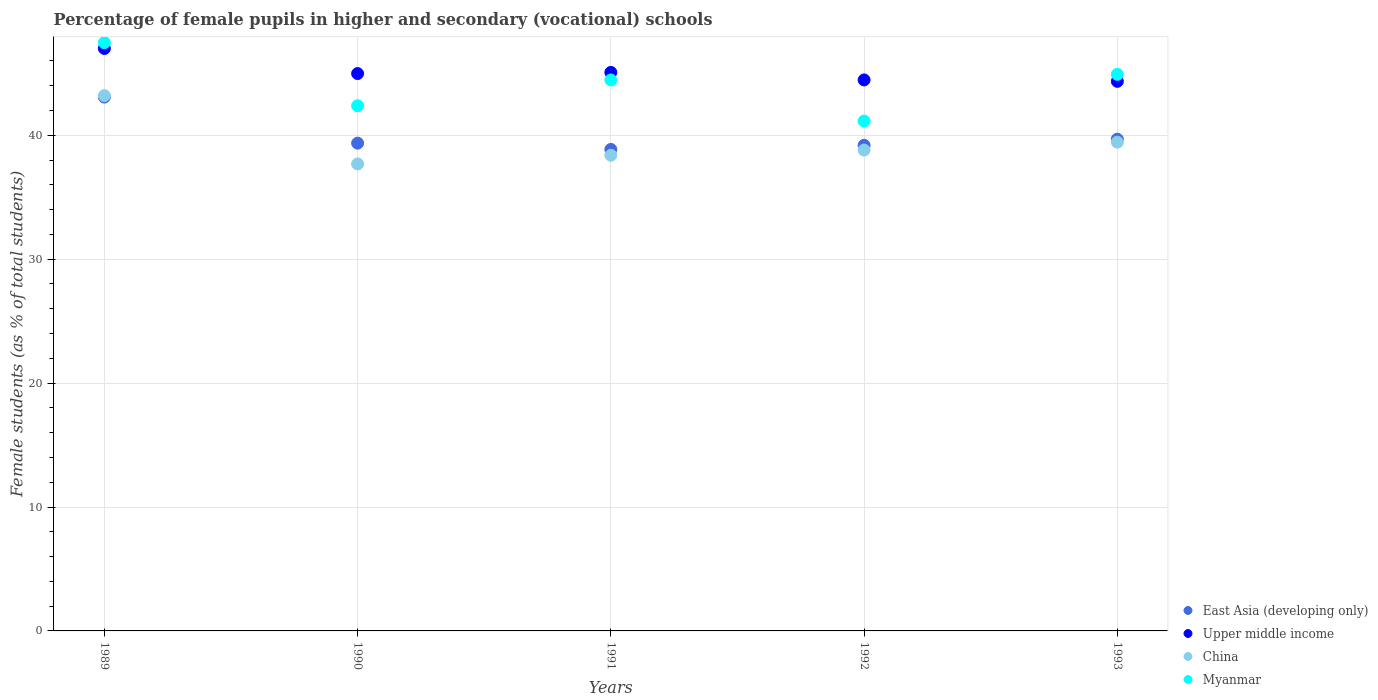How many different coloured dotlines are there?
Your answer should be very brief. 4. What is the percentage of female pupils in higher and secondary schools in Myanmar in 1989?
Your answer should be very brief. 47.48. Across all years, what is the maximum percentage of female pupils in higher and secondary schools in China?
Provide a short and direct response. 43.2. Across all years, what is the minimum percentage of female pupils in higher and secondary schools in East Asia (developing only)?
Offer a terse response. 38.86. What is the total percentage of female pupils in higher and secondary schools in East Asia (developing only) in the graph?
Keep it short and to the point. 200.19. What is the difference between the percentage of female pupils in higher and secondary schools in Upper middle income in 1989 and that in 1990?
Give a very brief answer. 2.03. What is the difference between the percentage of female pupils in higher and secondary schools in Myanmar in 1993 and the percentage of female pupils in higher and secondary schools in East Asia (developing only) in 1991?
Ensure brevity in your answer.  6.06. What is the average percentage of female pupils in higher and secondary schools in China per year?
Your answer should be very brief. 39.51. In the year 1993, what is the difference between the percentage of female pupils in higher and secondary schools in Upper middle income and percentage of female pupils in higher and secondary schools in China?
Give a very brief answer. 4.91. What is the ratio of the percentage of female pupils in higher and secondary schools in Upper middle income in 1991 to that in 1993?
Keep it short and to the point. 1.02. Is the percentage of female pupils in higher and secondary schools in China in 1992 less than that in 1993?
Your answer should be very brief. Yes. Is the difference between the percentage of female pupils in higher and secondary schools in Upper middle income in 1989 and 1993 greater than the difference between the percentage of female pupils in higher and secondary schools in China in 1989 and 1993?
Keep it short and to the point. No. What is the difference between the highest and the second highest percentage of female pupils in higher and secondary schools in East Asia (developing only)?
Ensure brevity in your answer.  3.4. What is the difference between the highest and the lowest percentage of female pupils in higher and secondary schools in Myanmar?
Offer a terse response. 6.33. Does the percentage of female pupils in higher and secondary schools in Upper middle income monotonically increase over the years?
Your response must be concise. No. Is the percentage of female pupils in higher and secondary schools in Upper middle income strictly greater than the percentage of female pupils in higher and secondary schools in China over the years?
Ensure brevity in your answer.  Yes. Is the percentage of female pupils in higher and secondary schools in Myanmar strictly less than the percentage of female pupils in higher and secondary schools in East Asia (developing only) over the years?
Your answer should be very brief. No. How many years are there in the graph?
Offer a terse response. 5. Does the graph contain any zero values?
Provide a succinct answer. No. What is the title of the graph?
Ensure brevity in your answer.  Percentage of female pupils in higher and secondary (vocational) schools. What is the label or title of the Y-axis?
Make the answer very short. Female students (as % of total students). What is the Female students (as % of total students) of East Asia (developing only) in 1989?
Offer a very short reply. 43.08. What is the Female students (as % of total students) in Upper middle income in 1989?
Provide a short and direct response. 47.01. What is the Female students (as % of total students) of China in 1989?
Your answer should be very brief. 43.2. What is the Female students (as % of total students) of Myanmar in 1989?
Your response must be concise. 47.48. What is the Female students (as % of total students) of East Asia (developing only) in 1990?
Ensure brevity in your answer.  39.37. What is the Female students (as % of total students) in Upper middle income in 1990?
Offer a very short reply. 44.98. What is the Female students (as % of total students) in China in 1990?
Offer a terse response. 37.69. What is the Female students (as % of total students) of Myanmar in 1990?
Your answer should be compact. 42.38. What is the Female students (as % of total students) of East Asia (developing only) in 1991?
Make the answer very short. 38.86. What is the Female students (as % of total students) in Upper middle income in 1991?
Your answer should be compact. 45.08. What is the Female students (as % of total students) in China in 1991?
Offer a very short reply. 38.39. What is the Female students (as % of total students) in Myanmar in 1991?
Your response must be concise. 44.47. What is the Female students (as % of total students) in East Asia (developing only) in 1992?
Provide a succinct answer. 39.19. What is the Female students (as % of total students) in Upper middle income in 1992?
Make the answer very short. 44.47. What is the Female students (as % of total students) in China in 1992?
Your answer should be very brief. 38.81. What is the Female students (as % of total students) of Myanmar in 1992?
Offer a very short reply. 41.15. What is the Female students (as % of total students) in East Asia (developing only) in 1993?
Make the answer very short. 39.68. What is the Female students (as % of total students) in Upper middle income in 1993?
Provide a short and direct response. 44.36. What is the Female students (as % of total students) in China in 1993?
Provide a short and direct response. 39.45. What is the Female students (as % of total students) of Myanmar in 1993?
Provide a succinct answer. 44.92. Across all years, what is the maximum Female students (as % of total students) of East Asia (developing only)?
Offer a terse response. 43.08. Across all years, what is the maximum Female students (as % of total students) in Upper middle income?
Ensure brevity in your answer.  47.01. Across all years, what is the maximum Female students (as % of total students) of China?
Your response must be concise. 43.2. Across all years, what is the maximum Female students (as % of total students) of Myanmar?
Offer a very short reply. 47.48. Across all years, what is the minimum Female students (as % of total students) in East Asia (developing only)?
Make the answer very short. 38.86. Across all years, what is the minimum Female students (as % of total students) in Upper middle income?
Make the answer very short. 44.36. Across all years, what is the minimum Female students (as % of total students) in China?
Keep it short and to the point. 37.69. Across all years, what is the minimum Female students (as % of total students) in Myanmar?
Give a very brief answer. 41.15. What is the total Female students (as % of total students) in East Asia (developing only) in the graph?
Offer a very short reply. 200.19. What is the total Female students (as % of total students) in Upper middle income in the graph?
Ensure brevity in your answer.  225.89. What is the total Female students (as % of total students) of China in the graph?
Your answer should be compact. 197.54. What is the total Female students (as % of total students) in Myanmar in the graph?
Your answer should be very brief. 220.4. What is the difference between the Female students (as % of total students) of East Asia (developing only) in 1989 and that in 1990?
Your answer should be compact. 3.72. What is the difference between the Female students (as % of total students) of Upper middle income in 1989 and that in 1990?
Your answer should be compact. 2.03. What is the difference between the Female students (as % of total students) in China in 1989 and that in 1990?
Keep it short and to the point. 5.51. What is the difference between the Female students (as % of total students) of Myanmar in 1989 and that in 1990?
Keep it short and to the point. 5.09. What is the difference between the Female students (as % of total students) in East Asia (developing only) in 1989 and that in 1991?
Make the answer very short. 4.22. What is the difference between the Female students (as % of total students) of Upper middle income in 1989 and that in 1991?
Your answer should be very brief. 1.93. What is the difference between the Female students (as % of total students) of China in 1989 and that in 1991?
Your answer should be very brief. 4.81. What is the difference between the Female students (as % of total students) in Myanmar in 1989 and that in 1991?
Your answer should be very brief. 3.01. What is the difference between the Female students (as % of total students) of East Asia (developing only) in 1989 and that in 1992?
Ensure brevity in your answer.  3.89. What is the difference between the Female students (as % of total students) in Upper middle income in 1989 and that in 1992?
Keep it short and to the point. 2.54. What is the difference between the Female students (as % of total students) of China in 1989 and that in 1992?
Give a very brief answer. 4.39. What is the difference between the Female students (as % of total students) of Myanmar in 1989 and that in 1992?
Keep it short and to the point. 6.33. What is the difference between the Female students (as % of total students) in East Asia (developing only) in 1989 and that in 1993?
Give a very brief answer. 3.4. What is the difference between the Female students (as % of total students) of Upper middle income in 1989 and that in 1993?
Provide a succinct answer. 2.65. What is the difference between the Female students (as % of total students) of China in 1989 and that in 1993?
Your answer should be very brief. 3.75. What is the difference between the Female students (as % of total students) of Myanmar in 1989 and that in 1993?
Keep it short and to the point. 2.56. What is the difference between the Female students (as % of total students) in East Asia (developing only) in 1990 and that in 1991?
Keep it short and to the point. 0.51. What is the difference between the Female students (as % of total students) of Upper middle income in 1990 and that in 1991?
Your response must be concise. -0.09. What is the difference between the Female students (as % of total students) in China in 1990 and that in 1991?
Your response must be concise. -0.7. What is the difference between the Female students (as % of total students) of Myanmar in 1990 and that in 1991?
Your answer should be compact. -2.08. What is the difference between the Female students (as % of total students) of East Asia (developing only) in 1990 and that in 1992?
Ensure brevity in your answer.  0.17. What is the difference between the Female students (as % of total students) in Upper middle income in 1990 and that in 1992?
Your answer should be very brief. 0.51. What is the difference between the Female students (as % of total students) of China in 1990 and that in 1992?
Your answer should be compact. -1.12. What is the difference between the Female students (as % of total students) of Myanmar in 1990 and that in 1992?
Your answer should be compact. 1.23. What is the difference between the Female students (as % of total students) in East Asia (developing only) in 1990 and that in 1993?
Make the answer very short. -0.32. What is the difference between the Female students (as % of total students) in Upper middle income in 1990 and that in 1993?
Make the answer very short. 0.63. What is the difference between the Female students (as % of total students) in China in 1990 and that in 1993?
Offer a very short reply. -1.76. What is the difference between the Female students (as % of total students) in Myanmar in 1990 and that in 1993?
Give a very brief answer. -2.54. What is the difference between the Female students (as % of total students) of East Asia (developing only) in 1991 and that in 1992?
Keep it short and to the point. -0.33. What is the difference between the Female students (as % of total students) of Upper middle income in 1991 and that in 1992?
Provide a succinct answer. 0.61. What is the difference between the Female students (as % of total students) of China in 1991 and that in 1992?
Your answer should be compact. -0.42. What is the difference between the Female students (as % of total students) in Myanmar in 1991 and that in 1992?
Offer a terse response. 3.32. What is the difference between the Female students (as % of total students) in East Asia (developing only) in 1991 and that in 1993?
Give a very brief answer. -0.82. What is the difference between the Female students (as % of total students) of Upper middle income in 1991 and that in 1993?
Provide a short and direct response. 0.72. What is the difference between the Female students (as % of total students) in China in 1991 and that in 1993?
Give a very brief answer. -1.06. What is the difference between the Female students (as % of total students) of Myanmar in 1991 and that in 1993?
Your answer should be compact. -0.45. What is the difference between the Female students (as % of total students) of East Asia (developing only) in 1992 and that in 1993?
Make the answer very short. -0.49. What is the difference between the Female students (as % of total students) of Upper middle income in 1992 and that in 1993?
Your answer should be compact. 0.12. What is the difference between the Female students (as % of total students) in China in 1992 and that in 1993?
Provide a succinct answer. -0.64. What is the difference between the Female students (as % of total students) of Myanmar in 1992 and that in 1993?
Offer a very short reply. -3.77. What is the difference between the Female students (as % of total students) of East Asia (developing only) in 1989 and the Female students (as % of total students) of Upper middle income in 1990?
Ensure brevity in your answer.  -1.9. What is the difference between the Female students (as % of total students) of East Asia (developing only) in 1989 and the Female students (as % of total students) of China in 1990?
Offer a very short reply. 5.4. What is the difference between the Female students (as % of total students) in East Asia (developing only) in 1989 and the Female students (as % of total students) in Myanmar in 1990?
Keep it short and to the point. 0.7. What is the difference between the Female students (as % of total students) in Upper middle income in 1989 and the Female students (as % of total students) in China in 1990?
Ensure brevity in your answer.  9.32. What is the difference between the Female students (as % of total students) of Upper middle income in 1989 and the Female students (as % of total students) of Myanmar in 1990?
Your answer should be compact. 4.62. What is the difference between the Female students (as % of total students) in China in 1989 and the Female students (as % of total students) in Myanmar in 1990?
Offer a very short reply. 0.82. What is the difference between the Female students (as % of total students) of East Asia (developing only) in 1989 and the Female students (as % of total students) of Upper middle income in 1991?
Keep it short and to the point. -1.99. What is the difference between the Female students (as % of total students) in East Asia (developing only) in 1989 and the Female students (as % of total students) in China in 1991?
Your answer should be compact. 4.69. What is the difference between the Female students (as % of total students) of East Asia (developing only) in 1989 and the Female students (as % of total students) of Myanmar in 1991?
Your response must be concise. -1.38. What is the difference between the Female students (as % of total students) of Upper middle income in 1989 and the Female students (as % of total students) of China in 1991?
Provide a succinct answer. 8.62. What is the difference between the Female students (as % of total students) of Upper middle income in 1989 and the Female students (as % of total students) of Myanmar in 1991?
Provide a succinct answer. 2.54. What is the difference between the Female students (as % of total students) of China in 1989 and the Female students (as % of total students) of Myanmar in 1991?
Make the answer very short. -1.27. What is the difference between the Female students (as % of total students) in East Asia (developing only) in 1989 and the Female students (as % of total students) in Upper middle income in 1992?
Ensure brevity in your answer.  -1.39. What is the difference between the Female students (as % of total students) in East Asia (developing only) in 1989 and the Female students (as % of total students) in China in 1992?
Give a very brief answer. 4.27. What is the difference between the Female students (as % of total students) in East Asia (developing only) in 1989 and the Female students (as % of total students) in Myanmar in 1992?
Your answer should be compact. 1.93. What is the difference between the Female students (as % of total students) of Upper middle income in 1989 and the Female students (as % of total students) of China in 1992?
Provide a short and direct response. 8.2. What is the difference between the Female students (as % of total students) in Upper middle income in 1989 and the Female students (as % of total students) in Myanmar in 1992?
Keep it short and to the point. 5.86. What is the difference between the Female students (as % of total students) in China in 1989 and the Female students (as % of total students) in Myanmar in 1992?
Ensure brevity in your answer.  2.05. What is the difference between the Female students (as % of total students) of East Asia (developing only) in 1989 and the Female students (as % of total students) of Upper middle income in 1993?
Your answer should be compact. -1.27. What is the difference between the Female students (as % of total students) of East Asia (developing only) in 1989 and the Female students (as % of total students) of China in 1993?
Offer a terse response. 3.64. What is the difference between the Female students (as % of total students) of East Asia (developing only) in 1989 and the Female students (as % of total students) of Myanmar in 1993?
Make the answer very short. -1.84. What is the difference between the Female students (as % of total students) of Upper middle income in 1989 and the Female students (as % of total students) of China in 1993?
Your response must be concise. 7.56. What is the difference between the Female students (as % of total students) in Upper middle income in 1989 and the Female students (as % of total students) in Myanmar in 1993?
Make the answer very short. 2.09. What is the difference between the Female students (as % of total students) of China in 1989 and the Female students (as % of total students) of Myanmar in 1993?
Offer a terse response. -1.72. What is the difference between the Female students (as % of total students) of East Asia (developing only) in 1990 and the Female students (as % of total students) of Upper middle income in 1991?
Your answer should be very brief. -5.71. What is the difference between the Female students (as % of total students) in East Asia (developing only) in 1990 and the Female students (as % of total students) in China in 1991?
Ensure brevity in your answer.  0.97. What is the difference between the Female students (as % of total students) of East Asia (developing only) in 1990 and the Female students (as % of total students) of Myanmar in 1991?
Your response must be concise. -5.1. What is the difference between the Female students (as % of total students) in Upper middle income in 1990 and the Female students (as % of total students) in China in 1991?
Provide a succinct answer. 6.59. What is the difference between the Female students (as % of total students) in Upper middle income in 1990 and the Female students (as % of total students) in Myanmar in 1991?
Ensure brevity in your answer.  0.52. What is the difference between the Female students (as % of total students) of China in 1990 and the Female students (as % of total students) of Myanmar in 1991?
Offer a very short reply. -6.78. What is the difference between the Female students (as % of total students) in East Asia (developing only) in 1990 and the Female students (as % of total students) in Upper middle income in 1992?
Your answer should be compact. -5.1. What is the difference between the Female students (as % of total students) of East Asia (developing only) in 1990 and the Female students (as % of total students) of China in 1992?
Your answer should be compact. 0.55. What is the difference between the Female students (as % of total students) in East Asia (developing only) in 1990 and the Female students (as % of total students) in Myanmar in 1992?
Provide a short and direct response. -1.78. What is the difference between the Female students (as % of total students) in Upper middle income in 1990 and the Female students (as % of total students) in China in 1992?
Make the answer very short. 6.17. What is the difference between the Female students (as % of total students) in Upper middle income in 1990 and the Female students (as % of total students) in Myanmar in 1992?
Offer a terse response. 3.83. What is the difference between the Female students (as % of total students) in China in 1990 and the Female students (as % of total students) in Myanmar in 1992?
Make the answer very short. -3.46. What is the difference between the Female students (as % of total students) in East Asia (developing only) in 1990 and the Female students (as % of total students) in Upper middle income in 1993?
Offer a very short reply. -4.99. What is the difference between the Female students (as % of total students) in East Asia (developing only) in 1990 and the Female students (as % of total students) in China in 1993?
Your response must be concise. -0.08. What is the difference between the Female students (as % of total students) in East Asia (developing only) in 1990 and the Female students (as % of total students) in Myanmar in 1993?
Ensure brevity in your answer.  -5.55. What is the difference between the Female students (as % of total students) in Upper middle income in 1990 and the Female students (as % of total students) in China in 1993?
Your response must be concise. 5.53. What is the difference between the Female students (as % of total students) in Upper middle income in 1990 and the Female students (as % of total students) in Myanmar in 1993?
Provide a succinct answer. 0.06. What is the difference between the Female students (as % of total students) in China in 1990 and the Female students (as % of total students) in Myanmar in 1993?
Your answer should be compact. -7.23. What is the difference between the Female students (as % of total students) in East Asia (developing only) in 1991 and the Female students (as % of total students) in Upper middle income in 1992?
Give a very brief answer. -5.61. What is the difference between the Female students (as % of total students) of East Asia (developing only) in 1991 and the Female students (as % of total students) of China in 1992?
Offer a terse response. 0.05. What is the difference between the Female students (as % of total students) of East Asia (developing only) in 1991 and the Female students (as % of total students) of Myanmar in 1992?
Your response must be concise. -2.29. What is the difference between the Female students (as % of total students) of Upper middle income in 1991 and the Female students (as % of total students) of China in 1992?
Keep it short and to the point. 6.26. What is the difference between the Female students (as % of total students) of Upper middle income in 1991 and the Female students (as % of total students) of Myanmar in 1992?
Give a very brief answer. 3.93. What is the difference between the Female students (as % of total students) of China in 1991 and the Female students (as % of total students) of Myanmar in 1992?
Offer a very short reply. -2.76. What is the difference between the Female students (as % of total students) in East Asia (developing only) in 1991 and the Female students (as % of total students) in Upper middle income in 1993?
Keep it short and to the point. -5.5. What is the difference between the Female students (as % of total students) of East Asia (developing only) in 1991 and the Female students (as % of total students) of China in 1993?
Ensure brevity in your answer.  -0.59. What is the difference between the Female students (as % of total students) of East Asia (developing only) in 1991 and the Female students (as % of total students) of Myanmar in 1993?
Offer a very short reply. -6.06. What is the difference between the Female students (as % of total students) in Upper middle income in 1991 and the Female students (as % of total students) in China in 1993?
Your response must be concise. 5.63. What is the difference between the Female students (as % of total students) of Upper middle income in 1991 and the Female students (as % of total students) of Myanmar in 1993?
Offer a terse response. 0.16. What is the difference between the Female students (as % of total students) of China in 1991 and the Female students (as % of total students) of Myanmar in 1993?
Provide a succinct answer. -6.53. What is the difference between the Female students (as % of total students) in East Asia (developing only) in 1992 and the Female students (as % of total students) in Upper middle income in 1993?
Your answer should be compact. -5.16. What is the difference between the Female students (as % of total students) of East Asia (developing only) in 1992 and the Female students (as % of total students) of China in 1993?
Ensure brevity in your answer.  -0.25. What is the difference between the Female students (as % of total students) of East Asia (developing only) in 1992 and the Female students (as % of total students) of Myanmar in 1993?
Your answer should be very brief. -5.73. What is the difference between the Female students (as % of total students) of Upper middle income in 1992 and the Female students (as % of total students) of China in 1993?
Provide a short and direct response. 5.02. What is the difference between the Female students (as % of total students) in Upper middle income in 1992 and the Female students (as % of total students) in Myanmar in 1993?
Provide a succinct answer. -0.45. What is the difference between the Female students (as % of total students) in China in 1992 and the Female students (as % of total students) in Myanmar in 1993?
Provide a short and direct response. -6.11. What is the average Female students (as % of total students) of East Asia (developing only) per year?
Provide a short and direct response. 40.04. What is the average Female students (as % of total students) of Upper middle income per year?
Keep it short and to the point. 45.18. What is the average Female students (as % of total students) in China per year?
Give a very brief answer. 39.51. What is the average Female students (as % of total students) in Myanmar per year?
Give a very brief answer. 44.08. In the year 1989, what is the difference between the Female students (as % of total students) in East Asia (developing only) and Female students (as % of total students) in Upper middle income?
Offer a terse response. -3.93. In the year 1989, what is the difference between the Female students (as % of total students) of East Asia (developing only) and Female students (as % of total students) of China?
Make the answer very short. -0.12. In the year 1989, what is the difference between the Female students (as % of total students) of East Asia (developing only) and Female students (as % of total students) of Myanmar?
Give a very brief answer. -4.4. In the year 1989, what is the difference between the Female students (as % of total students) of Upper middle income and Female students (as % of total students) of China?
Offer a very short reply. 3.81. In the year 1989, what is the difference between the Female students (as % of total students) of Upper middle income and Female students (as % of total students) of Myanmar?
Offer a very short reply. -0.47. In the year 1989, what is the difference between the Female students (as % of total students) of China and Female students (as % of total students) of Myanmar?
Ensure brevity in your answer.  -4.28. In the year 1990, what is the difference between the Female students (as % of total students) in East Asia (developing only) and Female students (as % of total students) in Upper middle income?
Keep it short and to the point. -5.62. In the year 1990, what is the difference between the Female students (as % of total students) in East Asia (developing only) and Female students (as % of total students) in China?
Offer a terse response. 1.68. In the year 1990, what is the difference between the Female students (as % of total students) of East Asia (developing only) and Female students (as % of total students) of Myanmar?
Your response must be concise. -3.02. In the year 1990, what is the difference between the Female students (as % of total students) in Upper middle income and Female students (as % of total students) in China?
Offer a very short reply. 7.3. In the year 1990, what is the difference between the Female students (as % of total students) of Upper middle income and Female students (as % of total students) of Myanmar?
Provide a succinct answer. 2.6. In the year 1990, what is the difference between the Female students (as % of total students) in China and Female students (as % of total students) in Myanmar?
Make the answer very short. -4.7. In the year 1991, what is the difference between the Female students (as % of total students) in East Asia (developing only) and Female students (as % of total students) in Upper middle income?
Provide a short and direct response. -6.22. In the year 1991, what is the difference between the Female students (as % of total students) of East Asia (developing only) and Female students (as % of total students) of China?
Ensure brevity in your answer.  0.47. In the year 1991, what is the difference between the Female students (as % of total students) in East Asia (developing only) and Female students (as % of total students) in Myanmar?
Your response must be concise. -5.61. In the year 1991, what is the difference between the Female students (as % of total students) in Upper middle income and Female students (as % of total students) in China?
Give a very brief answer. 6.68. In the year 1991, what is the difference between the Female students (as % of total students) in Upper middle income and Female students (as % of total students) in Myanmar?
Provide a succinct answer. 0.61. In the year 1991, what is the difference between the Female students (as % of total students) in China and Female students (as % of total students) in Myanmar?
Give a very brief answer. -6.08. In the year 1992, what is the difference between the Female students (as % of total students) of East Asia (developing only) and Female students (as % of total students) of Upper middle income?
Provide a short and direct response. -5.28. In the year 1992, what is the difference between the Female students (as % of total students) of East Asia (developing only) and Female students (as % of total students) of China?
Offer a very short reply. 0.38. In the year 1992, what is the difference between the Female students (as % of total students) of East Asia (developing only) and Female students (as % of total students) of Myanmar?
Make the answer very short. -1.96. In the year 1992, what is the difference between the Female students (as % of total students) in Upper middle income and Female students (as % of total students) in China?
Provide a short and direct response. 5.66. In the year 1992, what is the difference between the Female students (as % of total students) in Upper middle income and Female students (as % of total students) in Myanmar?
Your answer should be compact. 3.32. In the year 1992, what is the difference between the Female students (as % of total students) in China and Female students (as % of total students) in Myanmar?
Your answer should be compact. -2.34. In the year 1993, what is the difference between the Female students (as % of total students) of East Asia (developing only) and Female students (as % of total students) of Upper middle income?
Your answer should be very brief. -4.67. In the year 1993, what is the difference between the Female students (as % of total students) in East Asia (developing only) and Female students (as % of total students) in China?
Make the answer very short. 0.24. In the year 1993, what is the difference between the Female students (as % of total students) in East Asia (developing only) and Female students (as % of total students) in Myanmar?
Provide a short and direct response. -5.24. In the year 1993, what is the difference between the Female students (as % of total students) in Upper middle income and Female students (as % of total students) in China?
Your answer should be compact. 4.91. In the year 1993, what is the difference between the Female students (as % of total students) of Upper middle income and Female students (as % of total students) of Myanmar?
Your answer should be very brief. -0.56. In the year 1993, what is the difference between the Female students (as % of total students) in China and Female students (as % of total students) in Myanmar?
Offer a terse response. -5.47. What is the ratio of the Female students (as % of total students) of East Asia (developing only) in 1989 to that in 1990?
Offer a very short reply. 1.09. What is the ratio of the Female students (as % of total students) of Upper middle income in 1989 to that in 1990?
Provide a short and direct response. 1.04. What is the ratio of the Female students (as % of total students) in China in 1989 to that in 1990?
Provide a short and direct response. 1.15. What is the ratio of the Female students (as % of total students) of Myanmar in 1989 to that in 1990?
Your response must be concise. 1.12. What is the ratio of the Female students (as % of total students) in East Asia (developing only) in 1989 to that in 1991?
Give a very brief answer. 1.11. What is the ratio of the Female students (as % of total students) in Upper middle income in 1989 to that in 1991?
Your answer should be compact. 1.04. What is the ratio of the Female students (as % of total students) in China in 1989 to that in 1991?
Give a very brief answer. 1.13. What is the ratio of the Female students (as % of total students) of Myanmar in 1989 to that in 1991?
Keep it short and to the point. 1.07. What is the ratio of the Female students (as % of total students) of East Asia (developing only) in 1989 to that in 1992?
Provide a succinct answer. 1.1. What is the ratio of the Female students (as % of total students) in Upper middle income in 1989 to that in 1992?
Keep it short and to the point. 1.06. What is the ratio of the Female students (as % of total students) in China in 1989 to that in 1992?
Your answer should be compact. 1.11. What is the ratio of the Female students (as % of total students) in Myanmar in 1989 to that in 1992?
Your answer should be compact. 1.15. What is the ratio of the Female students (as % of total students) of East Asia (developing only) in 1989 to that in 1993?
Provide a short and direct response. 1.09. What is the ratio of the Female students (as % of total students) of Upper middle income in 1989 to that in 1993?
Keep it short and to the point. 1.06. What is the ratio of the Female students (as % of total students) of China in 1989 to that in 1993?
Make the answer very short. 1.1. What is the ratio of the Female students (as % of total students) of Myanmar in 1989 to that in 1993?
Ensure brevity in your answer.  1.06. What is the ratio of the Female students (as % of total students) of Upper middle income in 1990 to that in 1991?
Provide a succinct answer. 1. What is the ratio of the Female students (as % of total students) in China in 1990 to that in 1991?
Make the answer very short. 0.98. What is the ratio of the Female students (as % of total students) in Myanmar in 1990 to that in 1991?
Make the answer very short. 0.95. What is the ratio of the Female students (as % of total students) of East Asia (developing only) in 1990 to that in 1992?
Provide a short and direct response. 1. What is the ratio of the Female students (as % of total students) in Upper middle income in 1990 to that in 1992?
Give a very brief answer. 1.01. What is the ratio of the Female students (as % of total students) of China in 1990 to that in 1992?
Provide a succinct answer. 0.97. What is the ratio of the Female students (as % of total students) of Myanmar in 1990 to that in 1992?
Provide a short and direct response. 1.03. What is the ratio of the Female students (as % of total students) of Upper middle income in 1990 to that in 1993?
Your response must be concise. 1.01. What is the ratio of the Female students (as % of total students) in China in 1990 to that in 1993?
Make the answer very short. 0.96. What is the ratio of the Female students (as % of total students) of Myanmar in 1990 to that in 1993?
Offer a very short reply. 0.94. What is the ratio of the Female students (as % of total students) in East Asia (developing only) in 1991 to that in 1992?
Your answer should be very brief. 0.99. What is the ratio of the Female students (as % of total students) in Upper middle income in 1991 to that in 1992?
Keep it short and to the point. 1.01. What is the ratio of the Female students (as % of total students) of Myanmar in 1991 to that in 1992?
Provide a succinct answer. 1.08. What is the ratio of the Female students (as % of total students) of East Asia (developing only) in 1991 to that in 1993?
Provide a succinct answer. 0.98. What is the ratio of the Female students (as % of total students) of Upper middle income in 1991 to that in 1993?
Offer a terse response. 1.02. What is the ratio of the Female students (as % of total students) in China in 1991 to that in 1993?
Provide a succinct answer. 0.97. What is the ratio of the Female students (as % of total students) in Myanmar in 1991 to that in 1993?
Your answer should be compact. 0.99. What is the ratio of the Female students (as % of total students) in China in 1992 to that in 1993?
Make the answer very short. 0.98. What is the ratio of the Female students (as % of total students) of Myanmar in 1992 to that in 1993?
Offer a very short reply. 0.92. What is the difference between the highest and the second highest Female students (as % of total students) in East Asia (developing only)?
Your response must be concise. 3.4. What is the difference between the highest and the second highest Female students (as % of total students) in Upper middle income?
Give a very brief answer. 1.93. What is the difference between the highest and the second highest Female students (as % of total students) in China?
Your answer should be very brief. 3.75. What is the difference between the highest and the second highest Female students (as % of total students) in Myanmar?
Give a very brief answer. 2.56. What is the difference between the highest and the lowest Female students (as % of total students) of East Asia (developing only)?
Provide a succinct answer. 4.22. What is the difference between the highest and the lowest Female students (as % of total students) of Upper middle income?
Make the answer very short. 2.65. What is the difference between the highest and the lowest Female students (as % of total students) in China?
Ensure brevity in your answer.  5.51. What is the difference between the highest and the lowest Female students (as % of total students) of Myanmar?
Make the answer very short. 6.33. 